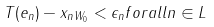Convert formula to latex. <formula><loc_0><loc_0><loc_500><loc_500>\| T ( e _ { n } ) - x _ { n } \| _ { W _ { 0 } } < \epsilon _ { n } f o r a l l n \in L</formula> 